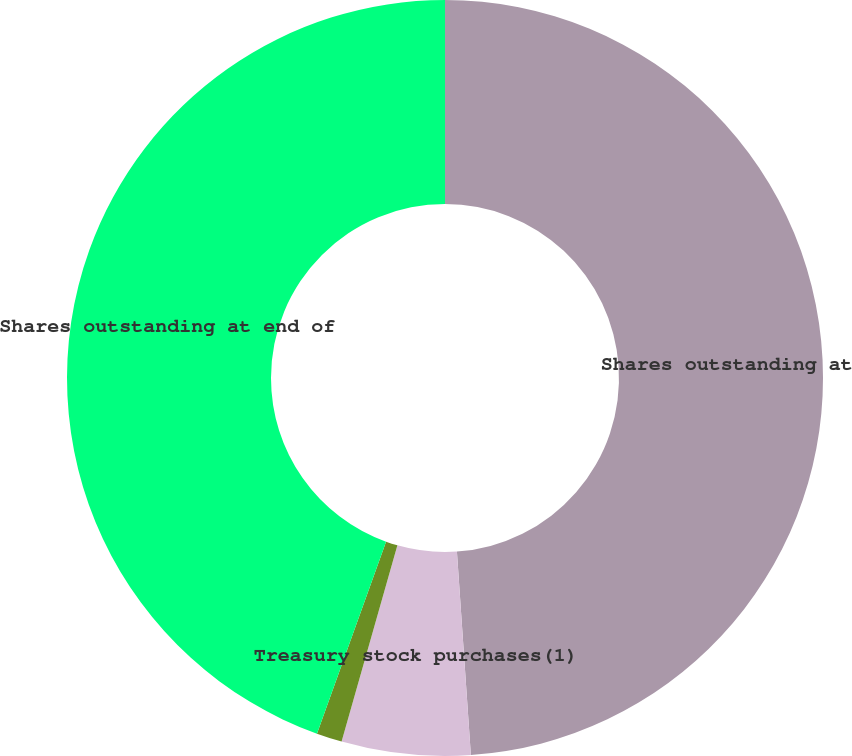Convert chart to OTSL. <chart><loc_0><loc_0><loc_500><loc_500><pie_chart><fcel>Shares outstanding at<fcel>Treasury stock purchases(1)<fcel>Other(2)<fcel>Shares outstanding at end of<nl><fcel>48.91%<fcel>5.5%<fcel>1.09%<fcel>44.5%<nl></chart> 